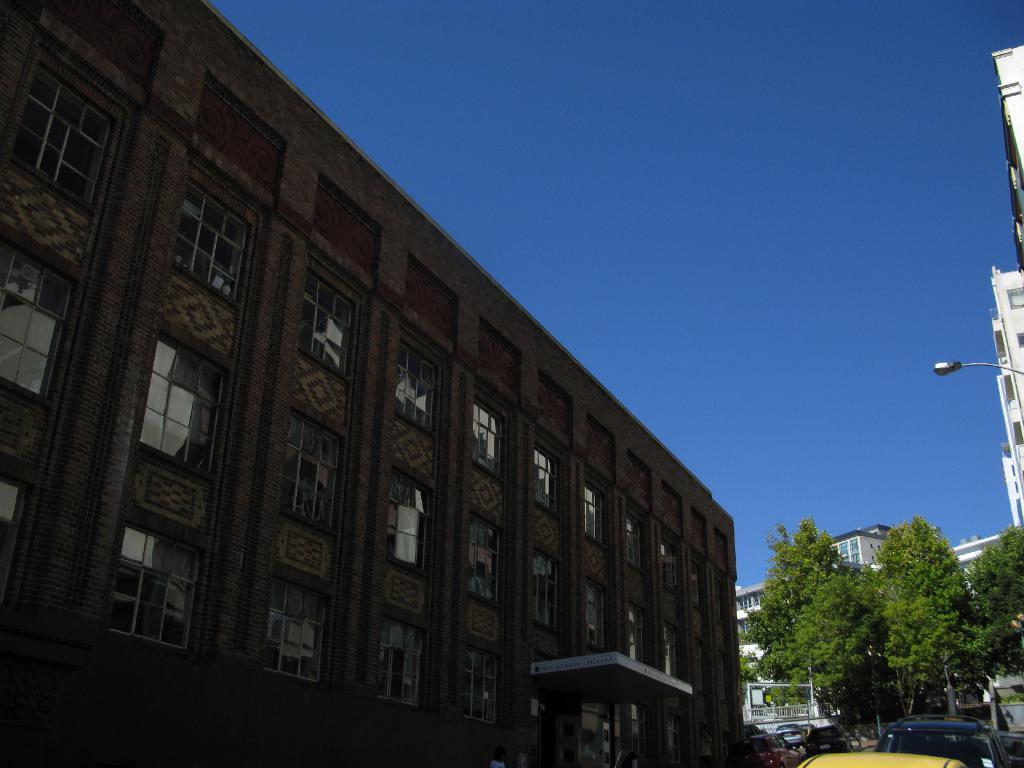Describe this image in one or two sentences. This image consists of buildings, trees, fence and fleets of vehicles on the road. At the top I can see the blue sky. This image is taken may be on the road. 